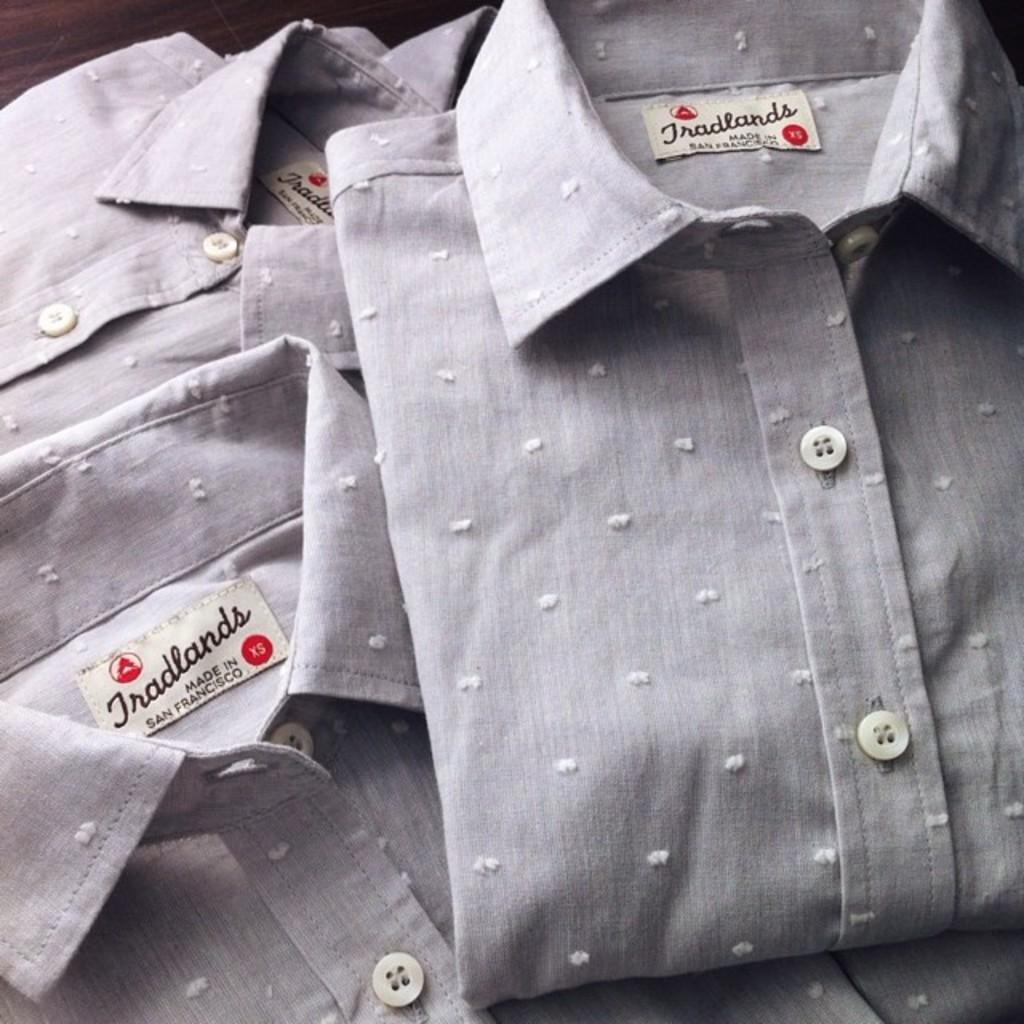What color are the shirts in the image? The shirts in the image are grey. What feature can be seen on the shirts? The shirts have tags on them. What information is provided on the tags? There is writing on the tags. Can you see any ducks or fowl in the image? No, there are no ducks or fowl present in the image; it only features grey color shirts with tags and writing on them. 